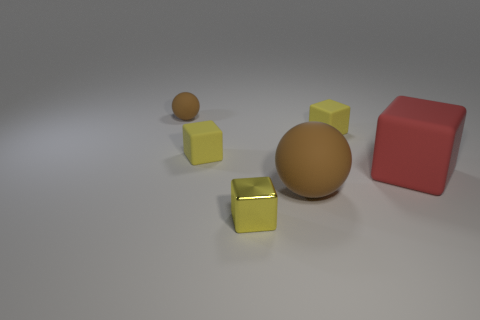Subtract all tiny cubes. How many cubes are left? 1 Subtract 1 spheres. How many spheres are left? 1 Add 4 big purple cylinders. How many objects exist? 10 Subtract all red cubes. How many cubes are left? 3 Add 3 yellow blocks. How many yellow blocks are left? 6 Add 3 red objects. How many red objects exist? 4 Subtract 0 blue cylinders. How many objects are left? 6 Subtract all balls. How many objects are left? 4 Subtract all brown blocks. Subtract all green cylinders. How many blocks are left? 4 Subtract all red cylinders. How many purple cubes are left? 0 